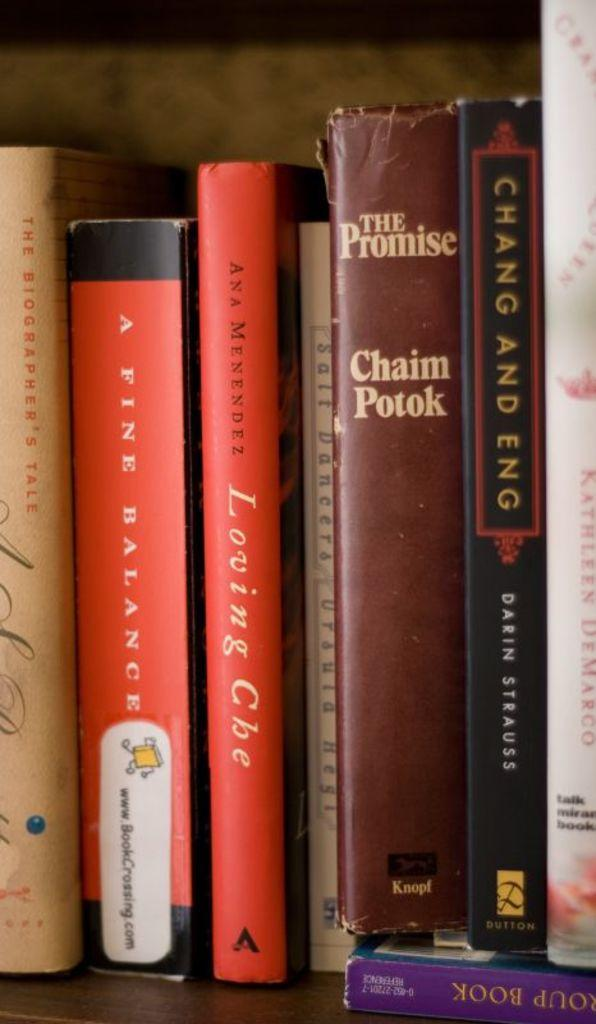<image>
Summarize the visual content of the image. A few Chinese literature books sit on a bookshelf. 